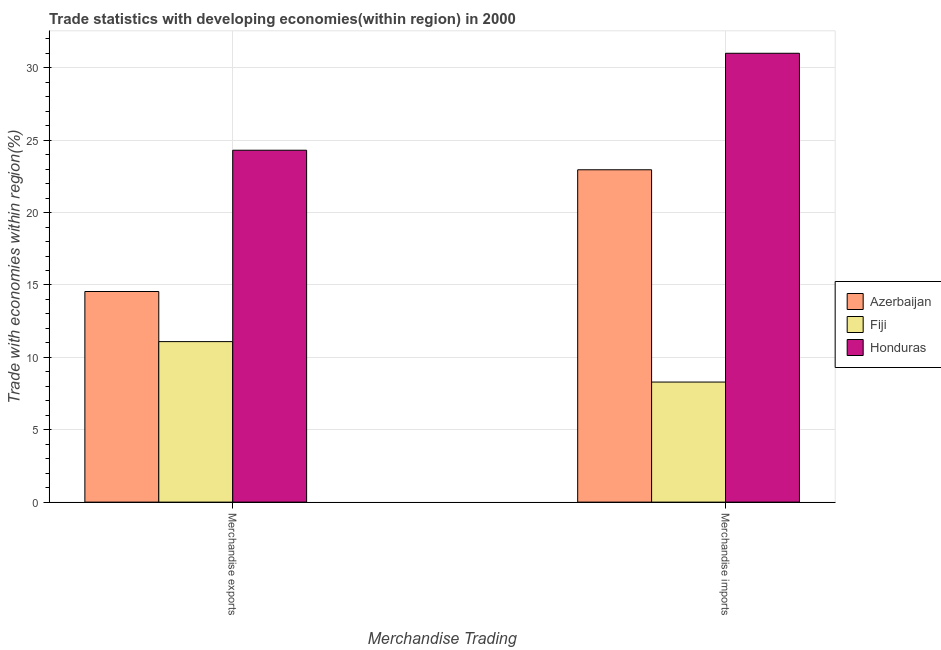How many different coloured bars are there?
Provide a succinct answer. 3. Are the number of bars per tick equal to the number of legend labels?
Your response must be concise. Yes. How many bars are there on the 2nd tick from the right?
Offer a terse response. 3. What is the label of the 1st group of bars from the left?
Your answer should be compact. Merchandise exports. What is the merchandise imports in Fiji?
Keep it short and to the point. 8.29. Across all countries, what is the maximum merchandise exports?
Offer a terse response. 24.31. Across all countries, what is the minimum merchandise exports?
Give a very brief answer. 11.09. In which country was the merchandise imports maximum?
Give a very brief answer. Honduras. In which country was the merchandise exports minimum?
Offer a terse response. Fiji. What is the total merchandise imports in the graph?
Give a very brief answer. 62.26. What is the difference between the merchandise imports in Honduras and that in Fiji?
Give a very brief answer. 22.71. What is the difference between the merchandise exports in Azerbaijan and the merchandise imports in Honduras?
Your response must be concise. -16.46. What is the average merchandise imports per country?
Your response must be concise. 20.75. What is the difference between the merchandise imports and merchandise exports in Honduras?
Provide a short and direct response. 6.7. What is the ratio of the merchandise exports in Fiji to that in Honduras?
Ensure brevity in your answer.  0.46. In how many countries, is the merchandise imports greater than the average merchandise imports taken over all countries?
Give a very brief answer. 2. What does the 1st bar from the left in Merchandise exports represents?
Make the answer very short. Azerbaijan. What does the 2nd bar from the right in Merchandise imports represents?
Offer a terse response. Fiji. How many bars are there?
Give a very brief answer. 6. Are all the bars in the graph horizontal?
Provide a succinct answer. No. What is the difference between two consecutive major ticks on the Y-axis?
Keep it short and to the point. 5. Are the values on the major ticks of Y-axis written in scientific E-notation?
Your answer should be compact. No. Does the graph contain any zero values?
Offer a very short reply. No. Where does the legend appear in the graph?
Your answer should be very brief. Center right. How many legend labels are there?
Provide a short and direct response. 3. How are the legend labels stacked?
Your answer should be compact. Vertical. What is the title of the graph?
Keep it short and to the point. Trade statistics with developing economies(within region) in 2000. Does "Croatia" appear as one of the legend labels in the graph?
Give a very brief answer. No. What is the label or title of the X-axis?
Ensure brevity in your answer.  Merchandise Trading. What is the label or title of the Y-axis?
Offer a very short reply. Trade with economies within region(%). What is the Trade with economies within region(%) in Azerbaijan in Merchandise exports?
Keep it short and to the point. 14.55. What is the Trade with economies within region(%) in Fiji in Merchandise exports?
Your response must be concise. 11.09. What is the Trade with economies within region(%) of Honduras in Merchandise exports?
Make the answer very short. 24.31. What is the Trade with economies within region(%) in Azerbaijan in Merchandise imports?
Offer a terse response. 22.96. What is the Trade with economies within region(%) of Fiji in Merchandise imports?
Ensure brevity in your answer.  8.29. What is the Trade with economies within region(%) in Honduras in Merchandise imports?
Provide a short and direct response. 31.01. Across all Merchandise Trading, what is the maximum Trade with economies within region(%) of Azerbaijan?
Keep it short and to the point. 22.96. Across all Merchandise Trading, what is the maximum Trade with economies within region(%) in Fiji?
Keep it short and to the point. 11.09. Across all Merchandise Trading, what is the maximum Trade with economies within region(%) in Honduras?
Give a very brief answer. 31.01. Across all Merchandise Trading, what is the minimum Trade with economies within region(%) of Azerbaijan?
Offer a terse response. 14.55. Across all Merchandise Trading, what is the minimum Trade with economies within region(%) of Fiji?
Keep it short and to the point. 8.29. Across all Merchandise Trading, what is the minimum Trade with economies within region(%) of Honduras?
Your response must be concise. 24.31. What is the total Trade with economies within region(%) in Azerbaijan in the graph?
Ensure brevity in your answer.  37.51. What is the total Trade with economies within region(%) in Fiji in the graph?
Offer a very short reply. 19.38. What is the total Trade with economies within region(%) in Honduras in the graph?
Provide a short and direct response. 55.31. What is the difference between the Trade with economies within region(%) of Azerbaijan in Merchandise exports and that in Merchandise imports?
Your answer should be compact. -8.41. What is the difference between the Trade with economies within region(%) in Fiji in Merchandise exports and that in Merchandise imports?
Offer a very short reply. 2.79. What is the difference between the Trade with economies within region(%) in Honduras in Merchandise exports and that in Merchandise imports?
Give a very brief answer. -6.7. What is the difference between the Trade with economies within region(%) of Azerbaijan in Merchandise exports and the Trade with economies within region(%) of Fiji in Merchandise imports?
Ensure brevity in your answer.  6.25. What is the difference between the Trade with economies within region(%) in Azerbaijan in Merchandise exports and the Trade with economies within region(%) in Honduras in Merchandise imports?
Offer a terse response. -16.46. What is the difference between the Trade with economies within region(%) in Fiji in Merchandise exports and the Trade with economies within region(%) in Honduras in Merchandise imports?
Make the answer very short. -19.92. What is the average Trade with economies within region(%) of Azerbaijan per Merchandise Trading?
Keep it short and to the point. 18.75. What is the average Trade with economies within region(%) of Fiji per Merchandise Trading?
Offer a terse response. 9.69. What is the average Trade with economies within region(%) of Honduras per Merchandise Trading?
Keep it short and to the point. 27.66. What is the difference between the Trade with economies within region(%) of Azerbaijan and Trade with economies within region(%) of Fiji in Merchandise exports?
Your response must be concise. 3.46. What is the difference between the Trade with economies within region(%) of Azerbaijan and Trade with economies within region(%) of Honduras in Merchandise exports?
Provide a succinct answer. -9.76. What is the difference between the Trade with economies within region(%) in Fiji and Trade with economies within region(%) in Honduras in Merchandise exports?
Your answer should be very brief. -13.22. What is the difference between the Trade with economies within region(%) of Azerbaijan and Trade with economies within region(%) of Fiji in Merchandise imports?
Make the answer very short. 14.66. What is the difference between the Trade with economies within region(%) in Azerbaijan and Trade with economies within region(%) in Honduras in Merchandise imports?
Your response must be concise. -8.05. What is the difference between the Trade with economies within region(%) in Fiji and Trade with economies within region(%) in Honduras in Merchandise imports?
Provide a short and direct response. -22.71. What is the ratio of the Trade with economies within region(%) in Azerbaijan in Merchandise exports to that in Merchandise imports?
Offer a terse response. 0.63. What is the ratio of the Trade with economies within region(%) in Fiji in Merchandise exports to that in Merchandise imports?
Offer a very short reply. 1.34. What is the ratio of the Trade with economies within region(%) in Honduras in Merchandise exports to that in Merchandise imports?
Ensure brevity in your answer.  0.78. What is the difference between the highest and the second highest Trade with economies within region(%) of Azerbaijan?
Keep it short and to the point. 8.41. What is the difference between the highest and the second highest Trade with economies within region(%) in Fiji?
Offer a terse response. 2.79. What is the difference between the highest and the second highest Trade with economies within region(%) in Honduras?
Offer a very short reply. 6.7. What is the difference between the highest and the lowest Trade with economies within region(%) in Azerbaijan?
Make the answer very short. 8.41. What is the difference between the highest and the lowest Trade with economies within region(%) in Fiji?
Make the answer very short. 2.79. What is the difference between the highest and the lowest Trade with economies within region(%) in Honduras?
Your response must be concise. 6.7. 